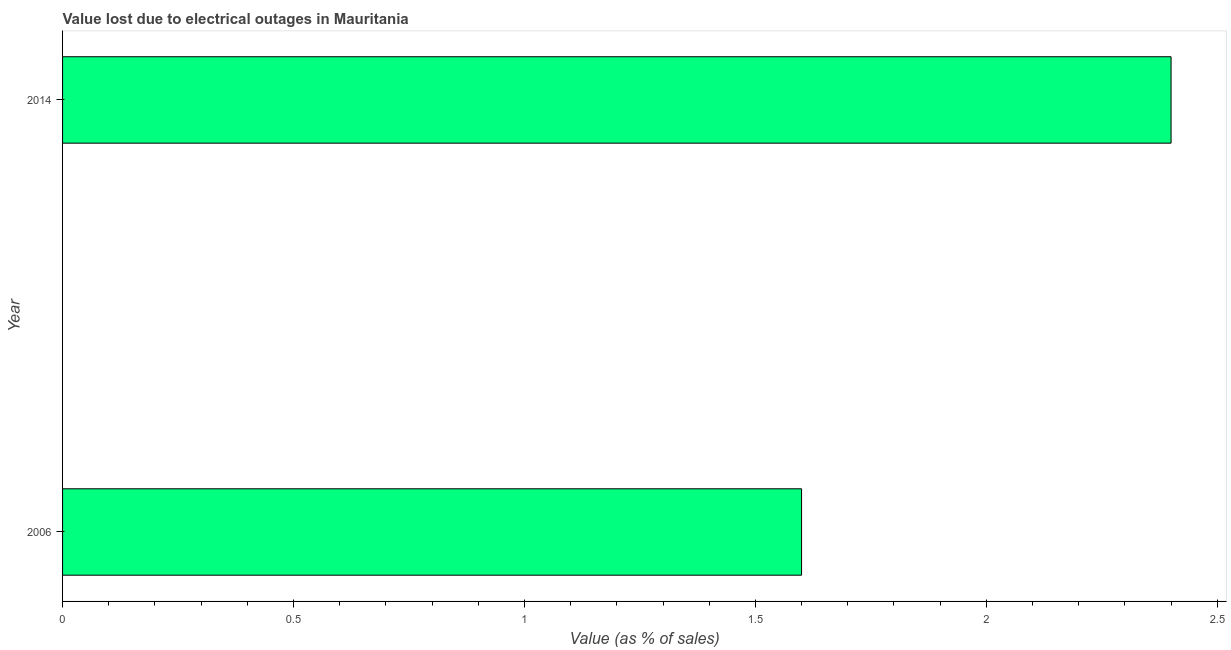Does the graph contain grids?
Give a very brief answer. No. What is the title of the graph?
Your response must be concise. Value lost due to electrical outages in Mauritania. What is the label or title of the X-axis?
Provide a short and direct response. Value (as % of sales). What is the label or title of the Y-axis?
Your answer should be very brief. Year. Across all years, what is the minimum value lost due to electrical outages?
Make the answer very short. 1.6. In which year was the value lost due to electrical outages maximum?
Your answer should be compact. 2014. In which year was the value lost due to electrical outages minimum?
Keep it short and to the point. 2006. What is the average value lost due to electrical outages per year?
Give a very brief answer. 2. What is the median value lost due to electrical outages?
Offer a terse response. 2. Do a majority of the years between 2014 and 2006 (inclusive) have value lost due to electrical outages greater than 2.1 %?
Ensure brevity in your answer.  No. What is the ratio of the value lost due to electrical outages in 2006 to that in 2014?
Offer a terse response. 0.67. Is the value lost due to electrical outages in 2006 less than that in 2014?
Offer a very short reply. Yes. In how many years, is the value lost due to electrical outages greater than the average value lost due to electrical outages taken over all years?
Your answer should be very brief. 1. How many bars are there?
Keep it short and to the point. 2. Are all the bars in the graph horizontal?
Offer a very short reply. Yes. Are the values on the major ticks of X-axis written in scientific E-notation?
Provide a succinct answer. No. What is the ratio of the Value (as % of sales) in 2006 to that in 2014?
Offer a terse response. 0.67. 